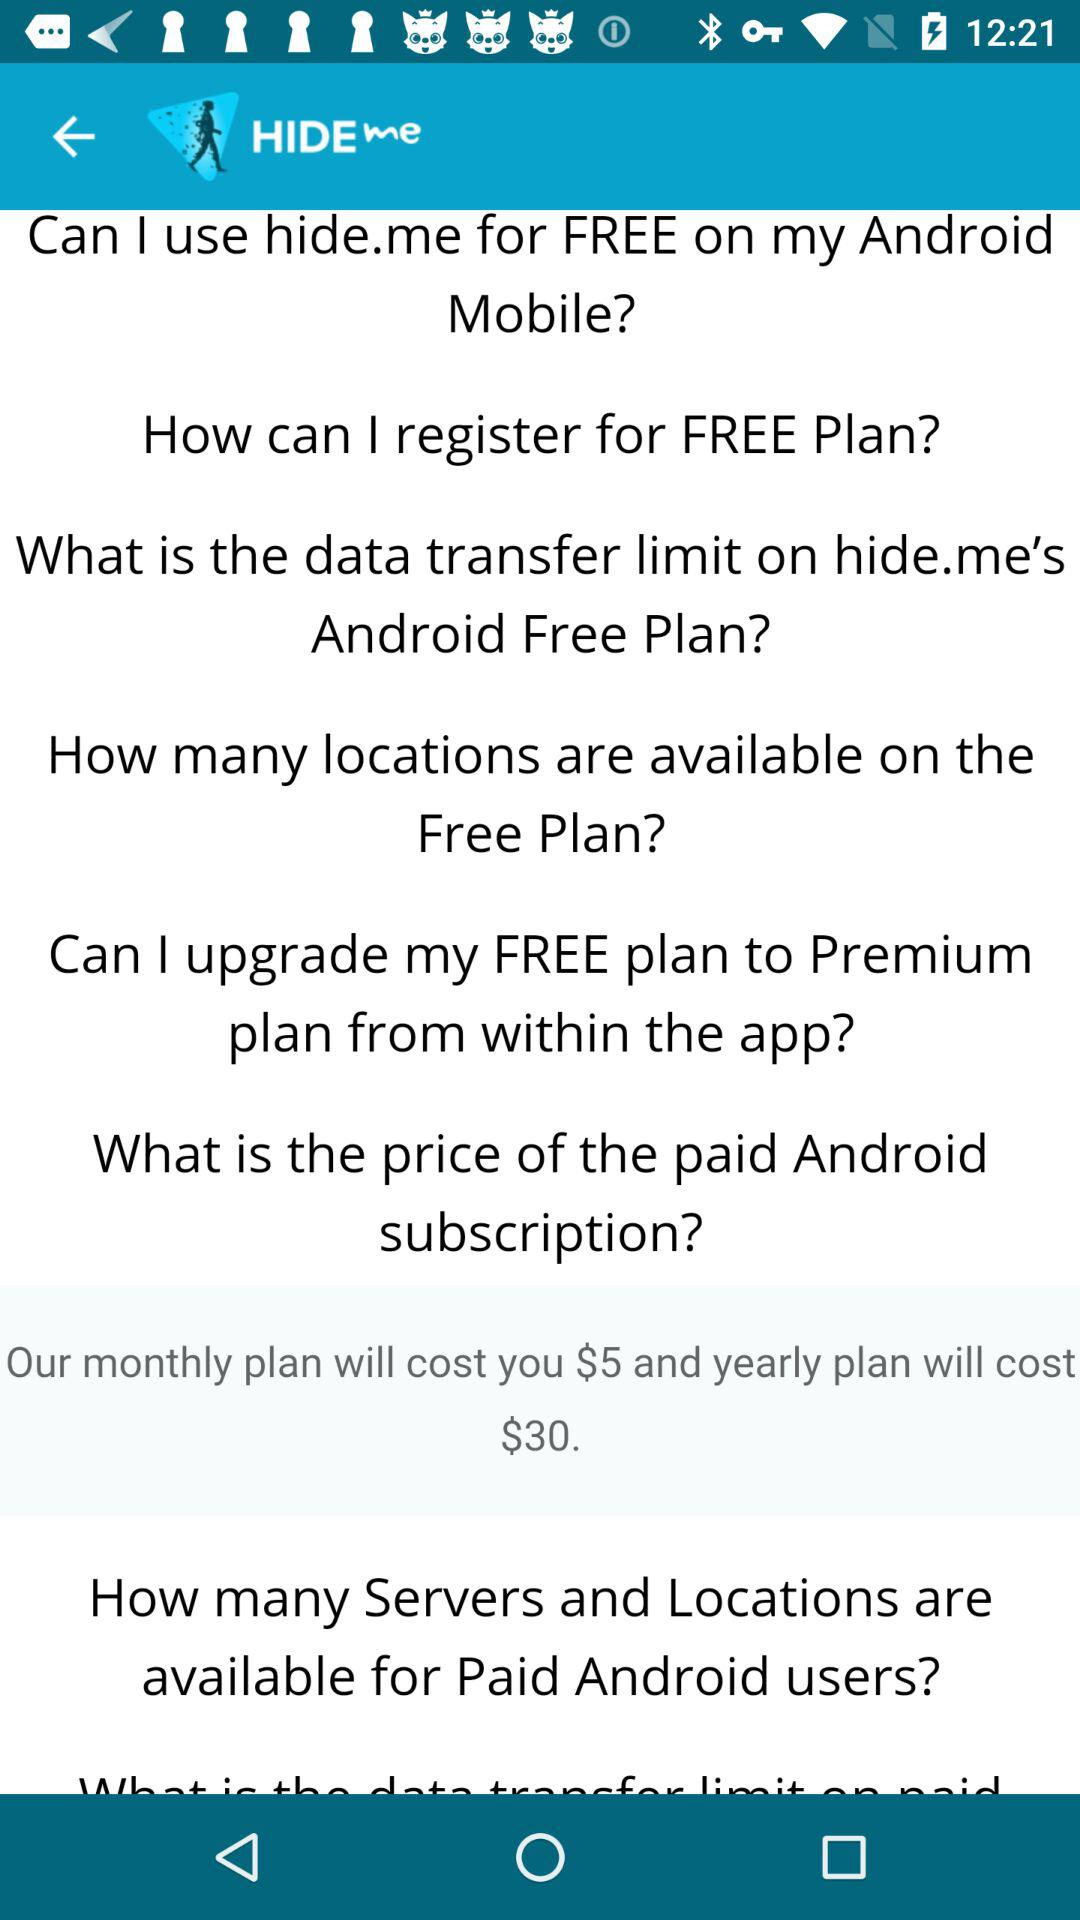What is the application name? The name of the application is "HIDE me". 